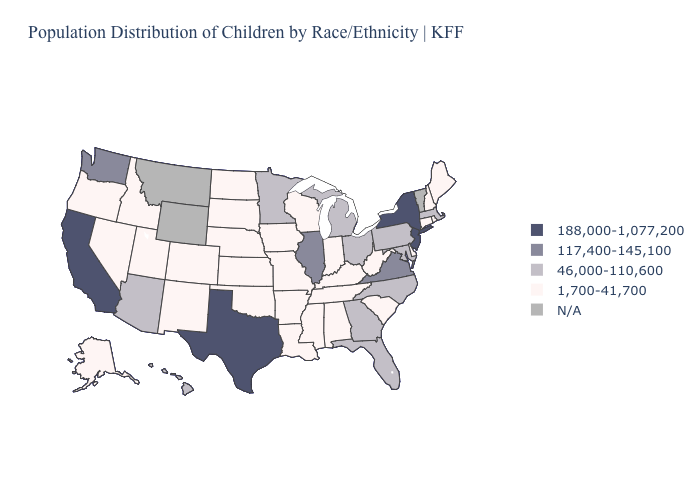Among the states that border Colorado , which have the highest value?
Keep it brief. Arizona. What is the highest value in the West ?
Give a very brief answer. 188,000-1,077,200. Is the legend a continuous bar?
Answer briefly. No. Does Alaska have the highest value in the USA?
Keep it brief. No. Name the states that have a value in the range 1,700-41,700?
Answer briefly. Alabama, Alaska, Arkansas, Colorado, Connecticut, Delaware, Idaho, Indiana, Iowa, Kansas, Kentucky, Louisiana, Maine, Mississippi, Missouri, Nebraska, Nevada, New Hampshire, New Mexico, North Dakota, Oklahoma, Oregon, Rhode Island, South Carolina, South Dakota, Tennessee, Utah, West Virginia, Wisconsin. Does Texas have the highest value in the South?
Answer briefly. Yes. What is the highest value in states that border Oklahoma?
Quick response, please. 188,000-1,077,200. Name the states that have a value in the range 117,400-145,100?
Short answer required. Illinois, Virginia, Washington. What is the highest value in the USA?
Keep it brief. 188,000-1,077,200. Name the states that have a value in the range 46,000-110,600?
Quick response, please. Arizona, Florida, Georgia, Hawaii, Maryland, Massachusetts, Michigan, Minnesota, North Carolina, Ohio, Pennsylvania. Name the states that have a value in the range N/A?
Give a very brief answer. Montana, Vermont, Wyoming. Name the states that have a value in the range 188,000-1,077,200?
Quick response, please. California, New Jersey, New York, Texas. What is the value of California?
Give a very brief answer. 188,000-1,077,200. What is the value of Texas?
Give a very brief answer. 188,000-1,077,200. Among the states that border Louisiana , which have the highest value?
Concise answer only. Texas. 